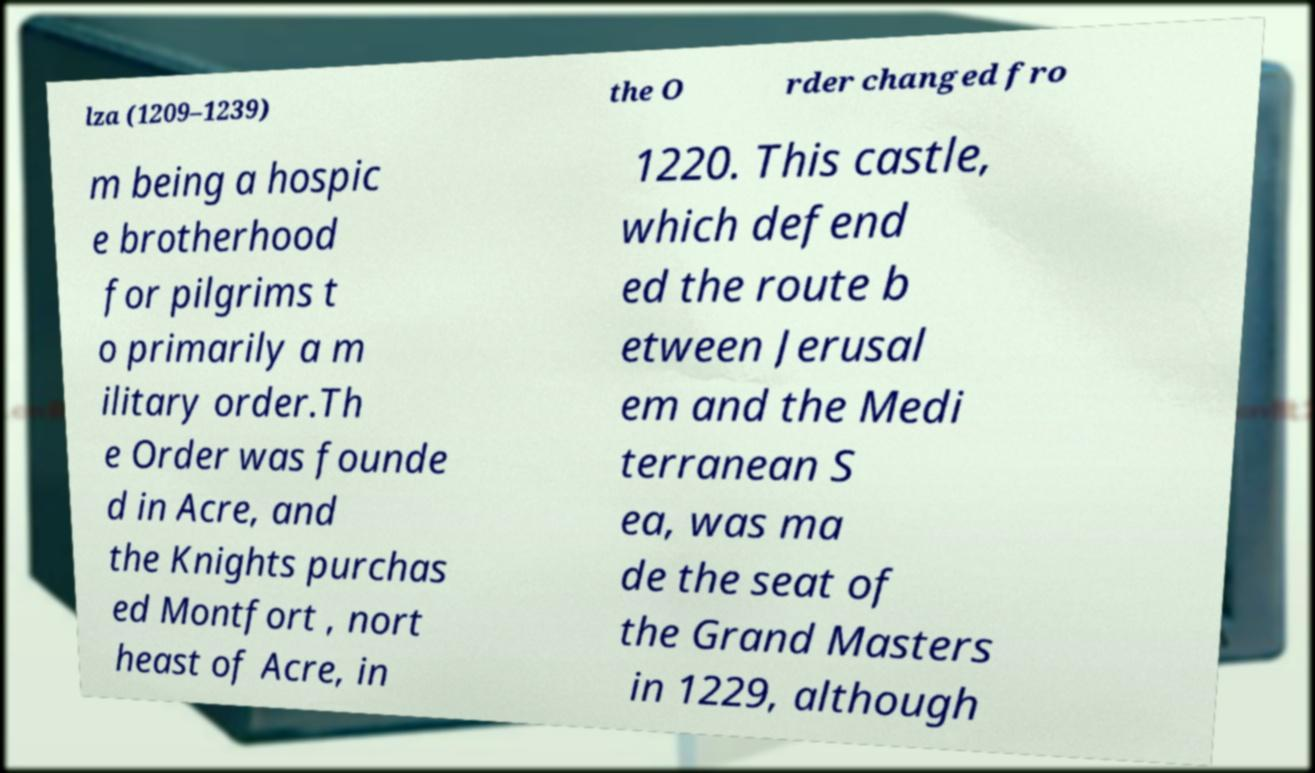Please identify and transcribe the text found in this image. lza (1209–1239) the O rder changed fro m being a hospic e brotherhood for pilgrims t o primarily a m ilitary order.Th e Order was founde d in Acre, and the Knights purchas ed Montfort , nort heast of Acre, in 1220. This castle, which defend ed the route b etween Jerusal em and the Medi terranean S ea, was ma de the seat of the Grand Masters in 1229, although 